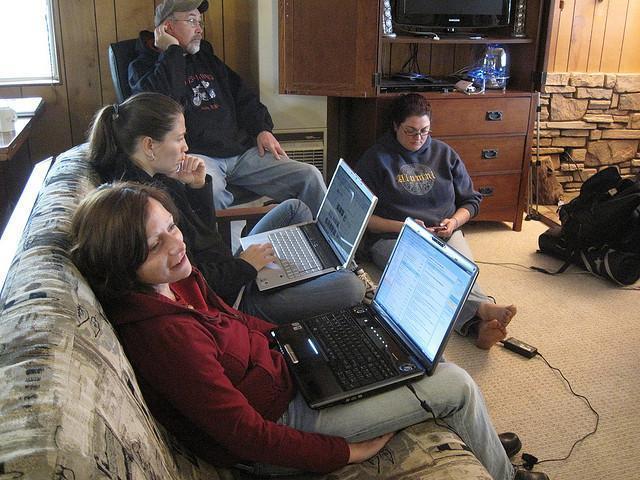How many laptops can be seen?
Give a very brief answer. 2. How many people are in the picture?
Give a very brief answer. 4. How many laptops are there?
Give a very brief answer. 2. How many people are there?
Give a very brief answer. 4. How many motorcycles are pictured?
Give a very brief answer. 0. 